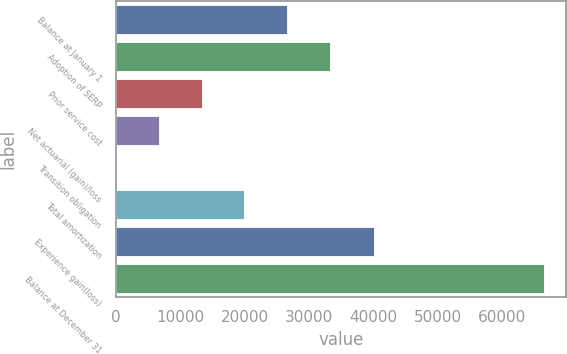Convert chart to OTSL. <chart><loc_0><loc_0><loc_500><loc_500><bar_chart><fcel>Balance at January 1<fcel>Adoption of SERP<fcel>Prior service cost<fcel>Net actuarial (gain)/loss<fcel>Transition obligation<fcel>Total amortization<fcel>Experience gain(loss)<fcel>Balance at December 31<nl><fcel>26624.6<fcel>33279<fcel>13315.8<fcel>6661.4<fcel>7<fcel>19970.2<fcel>40109<fcel>66551<nl></chart> 